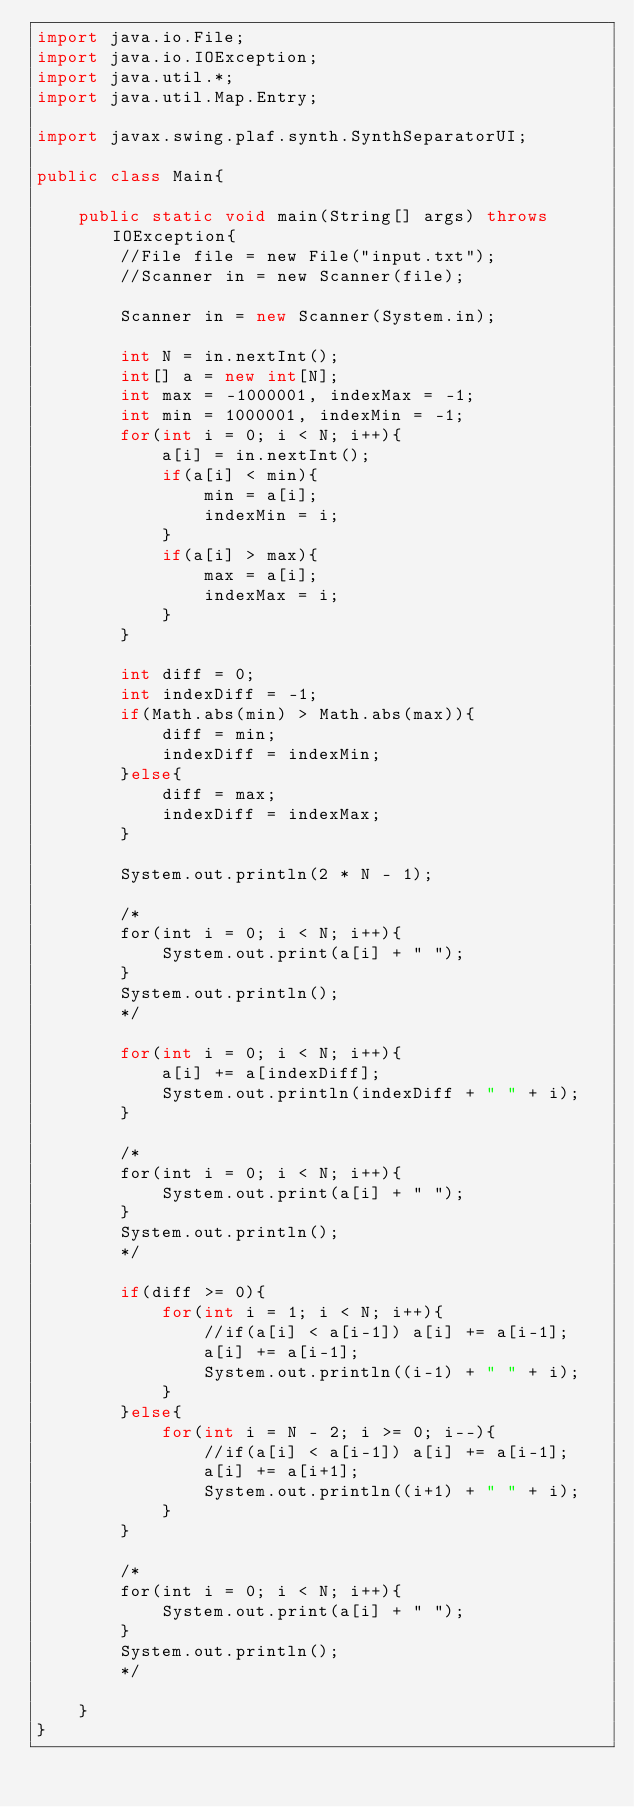Convert code to text. <code><loc_0><loc_0><loc_500><loc_500><_Java_>import java.io.File;
import java.io.IOException;
import java.util.*;
import java.util.Map.Entry;

import javax.swing.plaf.synth.SynthSeparatorUI;

public class Main{
	
	public static void main(String[] args) throws IOException{
		//File file = new File("input.txt");
		//Scanner in = new Scanner(file);
		
		Scanner in = new Scanner(System.in);
		
		int N = in.nextInt();
		int[] a = new int[N];
		int max = -1000001, indexMax = -1;
		int min = 1000001, indexMin = -1;
		for(int i = 0; i < N; i++){
			a[i] = in.nextInt();
			if(a[i] < min){
				min = a[i];
				indexMin = i;
			}
			if(a[i] > max){
				max = a[i];
				indexMax = i;
			}
		}
		
		int diff = 0;
		int indexDiff = -1;
		if(Math.abs(min) > Math.abs(max)){
			diff = min;
			indexDiff = indexMin;
		}else{
			diff = max;
			indexDiff = indexMax;
		}
		
		System.out.println(2 * N - 1);
		
		/*
		for(int i = 0; i < N; i++){
			System.out.print(a[i] + " ");
		}
		System.out.println();
		*/
		
		for(int i = 0; i < N; i++){
			a[i] += a[indexDiff];
			System.out.println(indexDiff + " " + i);
		}
		
		/*
		for(int i = 0; i < N; i++){
			System.out.print(a[i] + " ");
		}
		System.out.println();
		*/
		
		if(diff >= 0){
			for(int i = 1; i < N; i++){
				//if(a[i] < a[i-1]) a[i] += a[i-1];
				a[i] += a[i-1];
				System.out.println((i-1) + " " + i);
			}
		}else{
			for(int i = N - 2; i >= 0; i--){
				//if(a[i] < a[i-1]) a[i] += a[i-1];
				a[i] += a[i+1];
				System.out.println((i+1) + " " + i);
			}
		}
		
		/*
		for(int i = 0; i < N; i++){
			System.out.print(a[i] + " ");
		}
		System.out.println();
		*/
		
	}
}</code> 